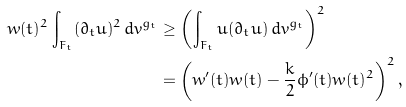Convert formula to latex. <formula><loc_0><loc_0><loc_500><loc_500>w ( t ) ^ { 2 } \int _ { F _ { t } } ( \partial _ { t } u ) ^ { 2 } \, d v ^ { g _ { t } } & \geq \left ( \int _ { F _ { t } } u ( \partial _ { t } u ) \, d v ^ { g _ { t } } \right ) ^ { 2 } \\ & = \left ( w ^ { \prime } ( t ) w ( t ) - \frac { k } { 2 } \phi ^ { \prime } ( t ) w ( t ) ^ { 2 } \right ) ^ { 2 } ,</formula> 